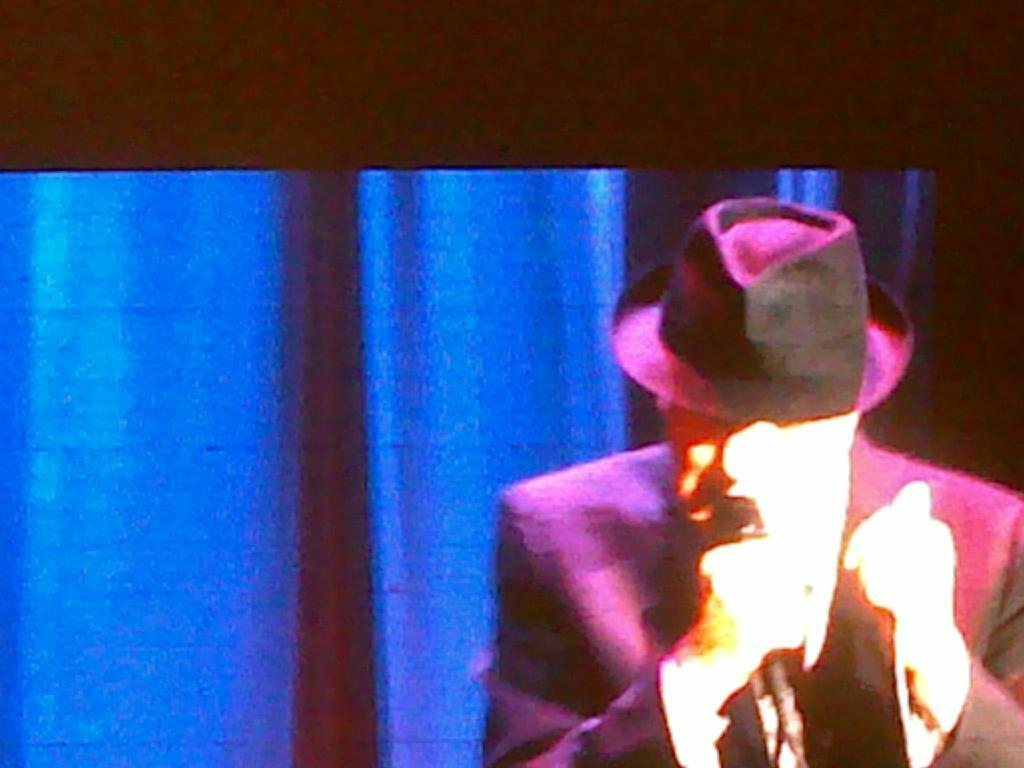What is the main object in the image? There is a screen in the image. What can be seen on the screen? A person is visible on the screen. Can you describe the person's appearance? The person is wearing a cap and holding a microphone. What is visible in the background of the image? There are curtains in the background of the image. Are there any plants visible on the screen? No, there are no plants visible on the screen; the person is holding a microphone. What type of art can be seen on the board in the image? There is no board present in the image, so it is not possible to determine if any art is displayed on it. 